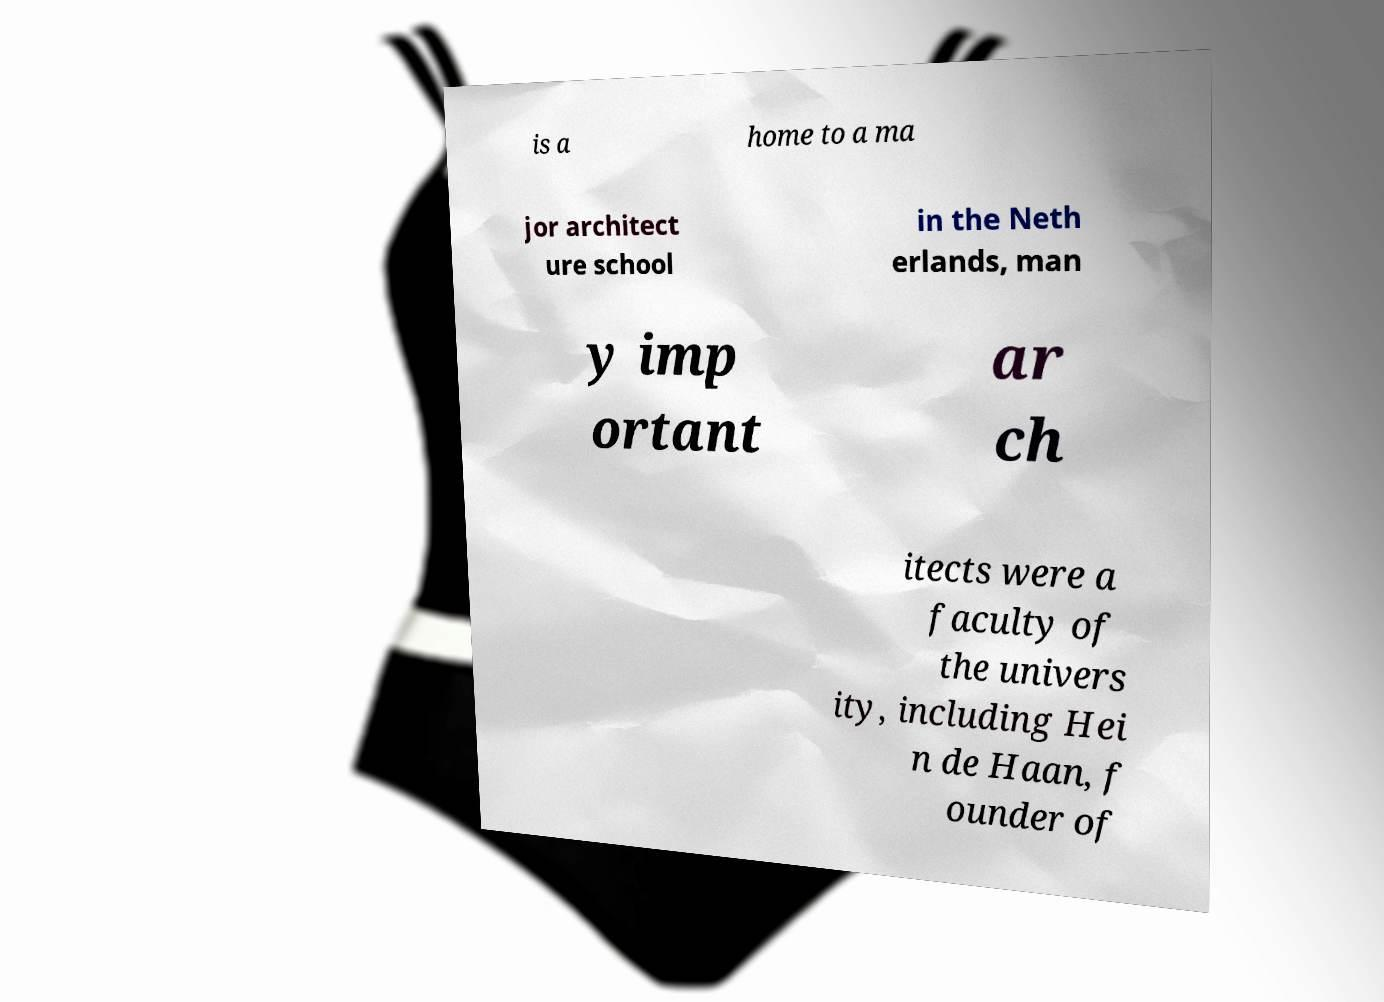Could you extract and type out the text from this image? is a home to a ma jor architect ure school in the Neth erlands, man y imp ortant ar ch itects were a faculty of the univers ity, including Hei n de Haan, f ounder of 